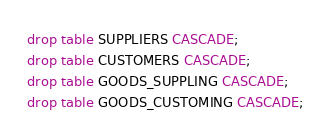<code> <loc_0><loc_0><loc_500><loc_500><_SQL_>drop table SUPPLIERS CASCADE;
drop table CUSTOMERS CASCADE;
drop table GOODS_SUPPLING CASCADE;
drop table GOODS_CUSTOMING CASCADE;</code> 